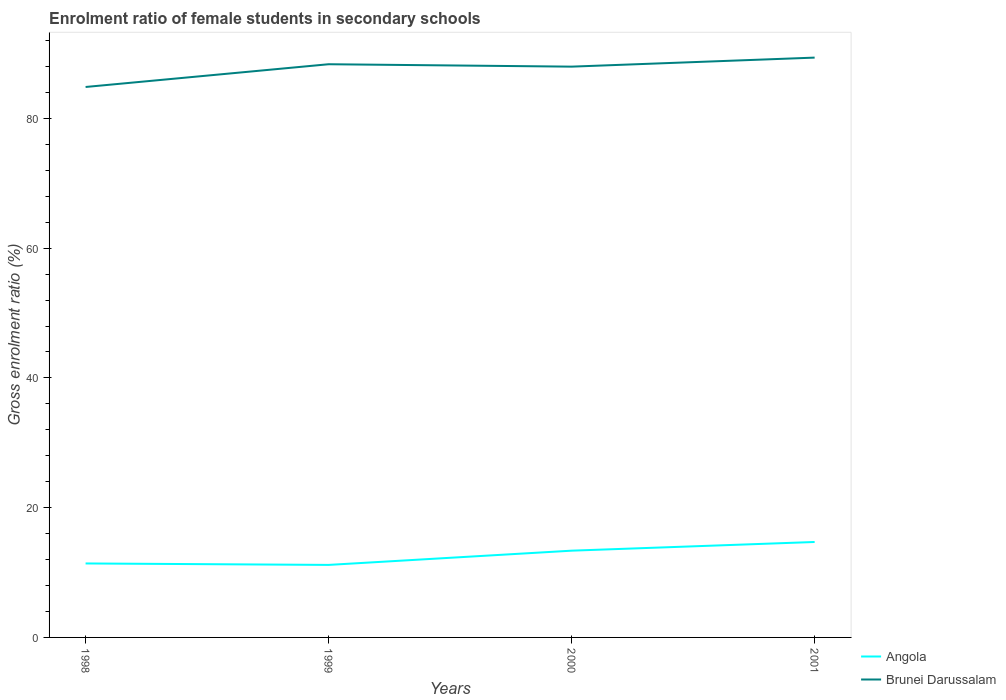How many different coloured lines are there?
Offer a terse response. 2. Across all years, what is the maximum enrolment ratio of female students in secondary schools in Brunei Darussalam?
Offer a very short reply. 84.85. What is the total enrolment ratio of female students in secondary schools in Angola in the graph?
Keep it short and to the point. 0.22. What is the difference between the highest and the second highest enrolment ratio of female students in secondary schools in Brunei Darussalam?
Provide a succinct answer. 4.53. Is the enrolment ratio of female students in secondary schools in Brunei Darussalam strictly greater than the enrolment ratio of female students in secondary schools in Angola over the years?
Offer a terse response. No. How many lines are there?
Offer a very short reply. 2. What is the difference between two consecutive major ticks on the Y-axis?
Ensure brevity in your answer.  20. Are the values on the major ticks of Y-axis written in scientific E-notation?
Provide a succinct answer. No. Does the graph contain any zero values?
Offer a very short reply. No. Does the graph contain grids?
Make the answer very short. No. How many legend labels are there?
Your answer should be compact. 2. What is the title of the graph?
Give a very brief answer. Enrolment ratio of female students in secondary schools. Does "Barbados" appear as one of the legend labels in the graph?
Provide a succinct answer. No. What is the label or title of the X-axis?
Keep it short and to the point. Years. What is the label or title of the Y-axis?
Your answer should be very brief. Gross enrolment ratio (%). What is the Gross enrolment ratio (%) of Angola in 1998?
Your response must be concise. 11.4. What is the Gross enrolment ratio (%) of Brunei Darussalam in 1998?
Give a very brief answer. 84.85. What is the Gross enrolment ratio (%) of Angola in 1999?
Your response must be concise. 11.18. What is the Gross enrolment ratio (%) of Brunei Darussalam in 1999?
Offer a terse response. 88.36. What is the Gross enrolment ratio (%) of Angola in 2000?
Provide a succinct answer. 13.37. What is the Gross enrolment ratio (%) of Brunei Darussalam in 2000?
Your answer should be very brief. 87.99. What is the Gross enrolment ratio (%) of Angola in 2001?
Provide a short and direct response. 14.71. What is the Gross enrolment ratio (%) of Brunei Darussalam in 2001?
Provide a short and direct response. 89.38. Across all years, what is the maximum Gross enrolment ratio (%) of Angola?
Make the answer very short. 14.71. Across all years, what is the maximum Gross enrolment ratio (%) in Brunei Darussalam?
Ensure brevity in your answer.  89.38. Across all years, what is the minimum Gross enrolment ratio (%) in Angola?
Make the answer very short. 11.18. Across all years, what is the minimum Gross enrolment ratio (%) in Brunei Darussalam?
Make the answer very short. 84.85. What is the total Gross enrolment ratio (%) of Angola in the graph?
Offer a very short reply. 50.67. What is the total Gross enrolment ratio (%) of Brunei Darussalam in the graph?
Keep it short and to the point. 350.58. What is the difference between the Gross enrolment ratio (%) in Angola in 1998 and that in 1999?
Your answer should be compact. 0.22. What is the difference between the Gross enrolment ratio (%) in Brunei Darussalam in 1998 and that in 1999?
Your response must be concise. -3.51. What is the difference between the Gross enrolment ratio (%) of Angola in 1998 and that in 2000?
Offer a very short reply. -1.97. What is the difference between the Gross enrolment ratio (%) of Brunei Darussalam in 1998 and that in 2000?
Your answer should be compact. -3.13. What is the difference between the Gross enrolment ratio (%) in Angola in 1998 and that in 2001?
Ensure brevity in your answer.  -3.31. What is the difference between the Gross enrolment ratio (%) in Brunei Darussalam in 1998 and that in 2001?
Give a very brief answer. -4.53. What is the difference between the Gross enrolment ratio (%) of Angola in 1999 and that in 2000?
Ensure brevity in your answer.  -2.2. What is the difference between the Gross enrolment ratio (%) of Brunei Darussalam in 1999 and that in 2000?
Give a very brief answer. 0.37. What is the difference between the Gross enrolment ratio (%) of Angola in 1999 and that in 2001?
Your answer should be very brief. -3.53. What is the difference between the Gross enrolment ratio (%) of Brunei Darussalam in 1999 and that in 2001?
Your answer should be compact. -1.02. What is the difference between the Gross enrolment ratio (%) in Angola in 2000 and that in 2001?
Offer a very short reply. -1.34. What is the difference between the Gross enrolment ratio (%) in Brunei Darussalam in 2000 and that in 2001?
Ensure brevity in your answer.  -1.39. What is the difference between the Gross enrolment ratio (%) of Angola in 1998 and the Gross enrolment ratio (%) of Brunei Darussalam in 1999?
Ensure brevity in your answer.  -76.96. What is the difference between the Gross enrolment ratio (%) in Angola in 1998 and the Gross enrolment ratio (%) in Brunei Darussalam in 2000?
Your answer should be compact. -76.58. What is the difference between the Gross enrolment ratio (%) of Angola in 1998 and the Gross enrolment ratio (%) of Brunei Darussalam in 2001?
Provide a short and direct response. -77.98. What is the difference between the Gross enrolment ratio (%) in Angola in 1999 and the Gross enrolment ratio (%) in Brunei Darussalam in 2000?
Make the answer very short. -76.81. What is the difference between the Gross enrolment ratio (%) of Angola in 1999 and the Gross enrolment ratio (%) of Brunei Darussalam in 2001?
Make the answer very short. -78.2. What is the difference between the Gross enrolment ratio (%) in Angola in 2000 and the Gross enrolment ratio (%) in Brunei Darussalam in 2001?
Offer a terse response. -76.01. What is the average Gross enrolment ratio (%) in Angola per year?
Offer a terse response. 12.67. What is the average Gross enrolment ratio (%) in Brunei Darussalam per year?
Your answer should be compact. 87.64. In the year 1998, what is the difference between the Gross enrolment ratio (%) of Angola and Gross enrolment ratio (%) of Brunei Darussalam?
Ensure brevity in your answer.  -73.45. In the year 1999, what is the difference between the Gross enrolment ratio (%) of Angola and Gross enrolment ratio (%) of Brunei Darussalam?
Your answer should be very brief. -77.18. In the year 2000, what is the difference between the Gross enrolment ratio (%) of Angola and Gross enrolment ratio (%) of Brunei Darussalam?
Your response must be concise. -74.61. In the year 2001, what is the difference between the Gross enrolment ratio (%) in Angola and Gross enrolment ratio (%) in Brunei Darussalam?
Keep it short and to the point. -74.67. What is the ratio of the Gross enrolment ratio (%) in Angola in 1998 to that in 1999?
Provide a succinct answer. 1.02. What is the ratio of the Gross enrolment ratio (%) of Brunei Darussalam in 1998 to that in 1999?
Your answer should be compact. 0.96. What is the ratio of the Gross enrolment ratio (%) in Angola in 1998 to that in 2000?
Your answer should be compact. 0.85. What is the ratio of the Gross enrolment ratio (%) of Brunei Darussalam in 1998 to that in 2000?
Give a very brief answer. 0.96. What is the ratio of the Gross enrolment ratio (%) of Angola in 1998 to that in 2001?
Your answer should be very brief. 0.78. What is the ratio of the Gross enrolment ratio (%) in Brunei Darussalam in 1998 to that in 2001?
Offer a very short reply. 0.95. What is the ratio of the Gross enrolment ratio (%) in Angola in 1999 to that in 2000?
Your answer should be compact. 0.84. What is the ratio of the Gross enrolment ratio (%) of Brunei Darussalam in 1999 to that in 2000?
Offer a terse response. 1. What is the ratio of the Gross enrolment ratio (%) of Angola in 1999 to that in 2001?
Make the answer very short. 0.76. What is the ratio of the Gross enrolment ratio (%) of Angola in 2000 to that in 2001?
Your answer should be compact. 0.91. What is the ratio of the Gross enrolment ratio (%) of Brunei Darussalam in 2000 to that in 2001?
Offer a very short reply. 0.98. What is the difference between the highest and the second highest Gross enrolment ratio (%) of Angola?
Offer a terse response. 1.34. What is the difference between the highest and the second highest Gross enrolment ratio (%) in Brunei Darussalam?
Provide a short and direct response. 1.02. What is the difference between the highest and the lowest Gross enrolment ratio (%) in Angola?
Your response must be concise. 3.53. What is the difference between the highest and the lowest Gross enrolment ratio (%) of Brunei Darussalam?
Your answer should be very brief. 4.53. 